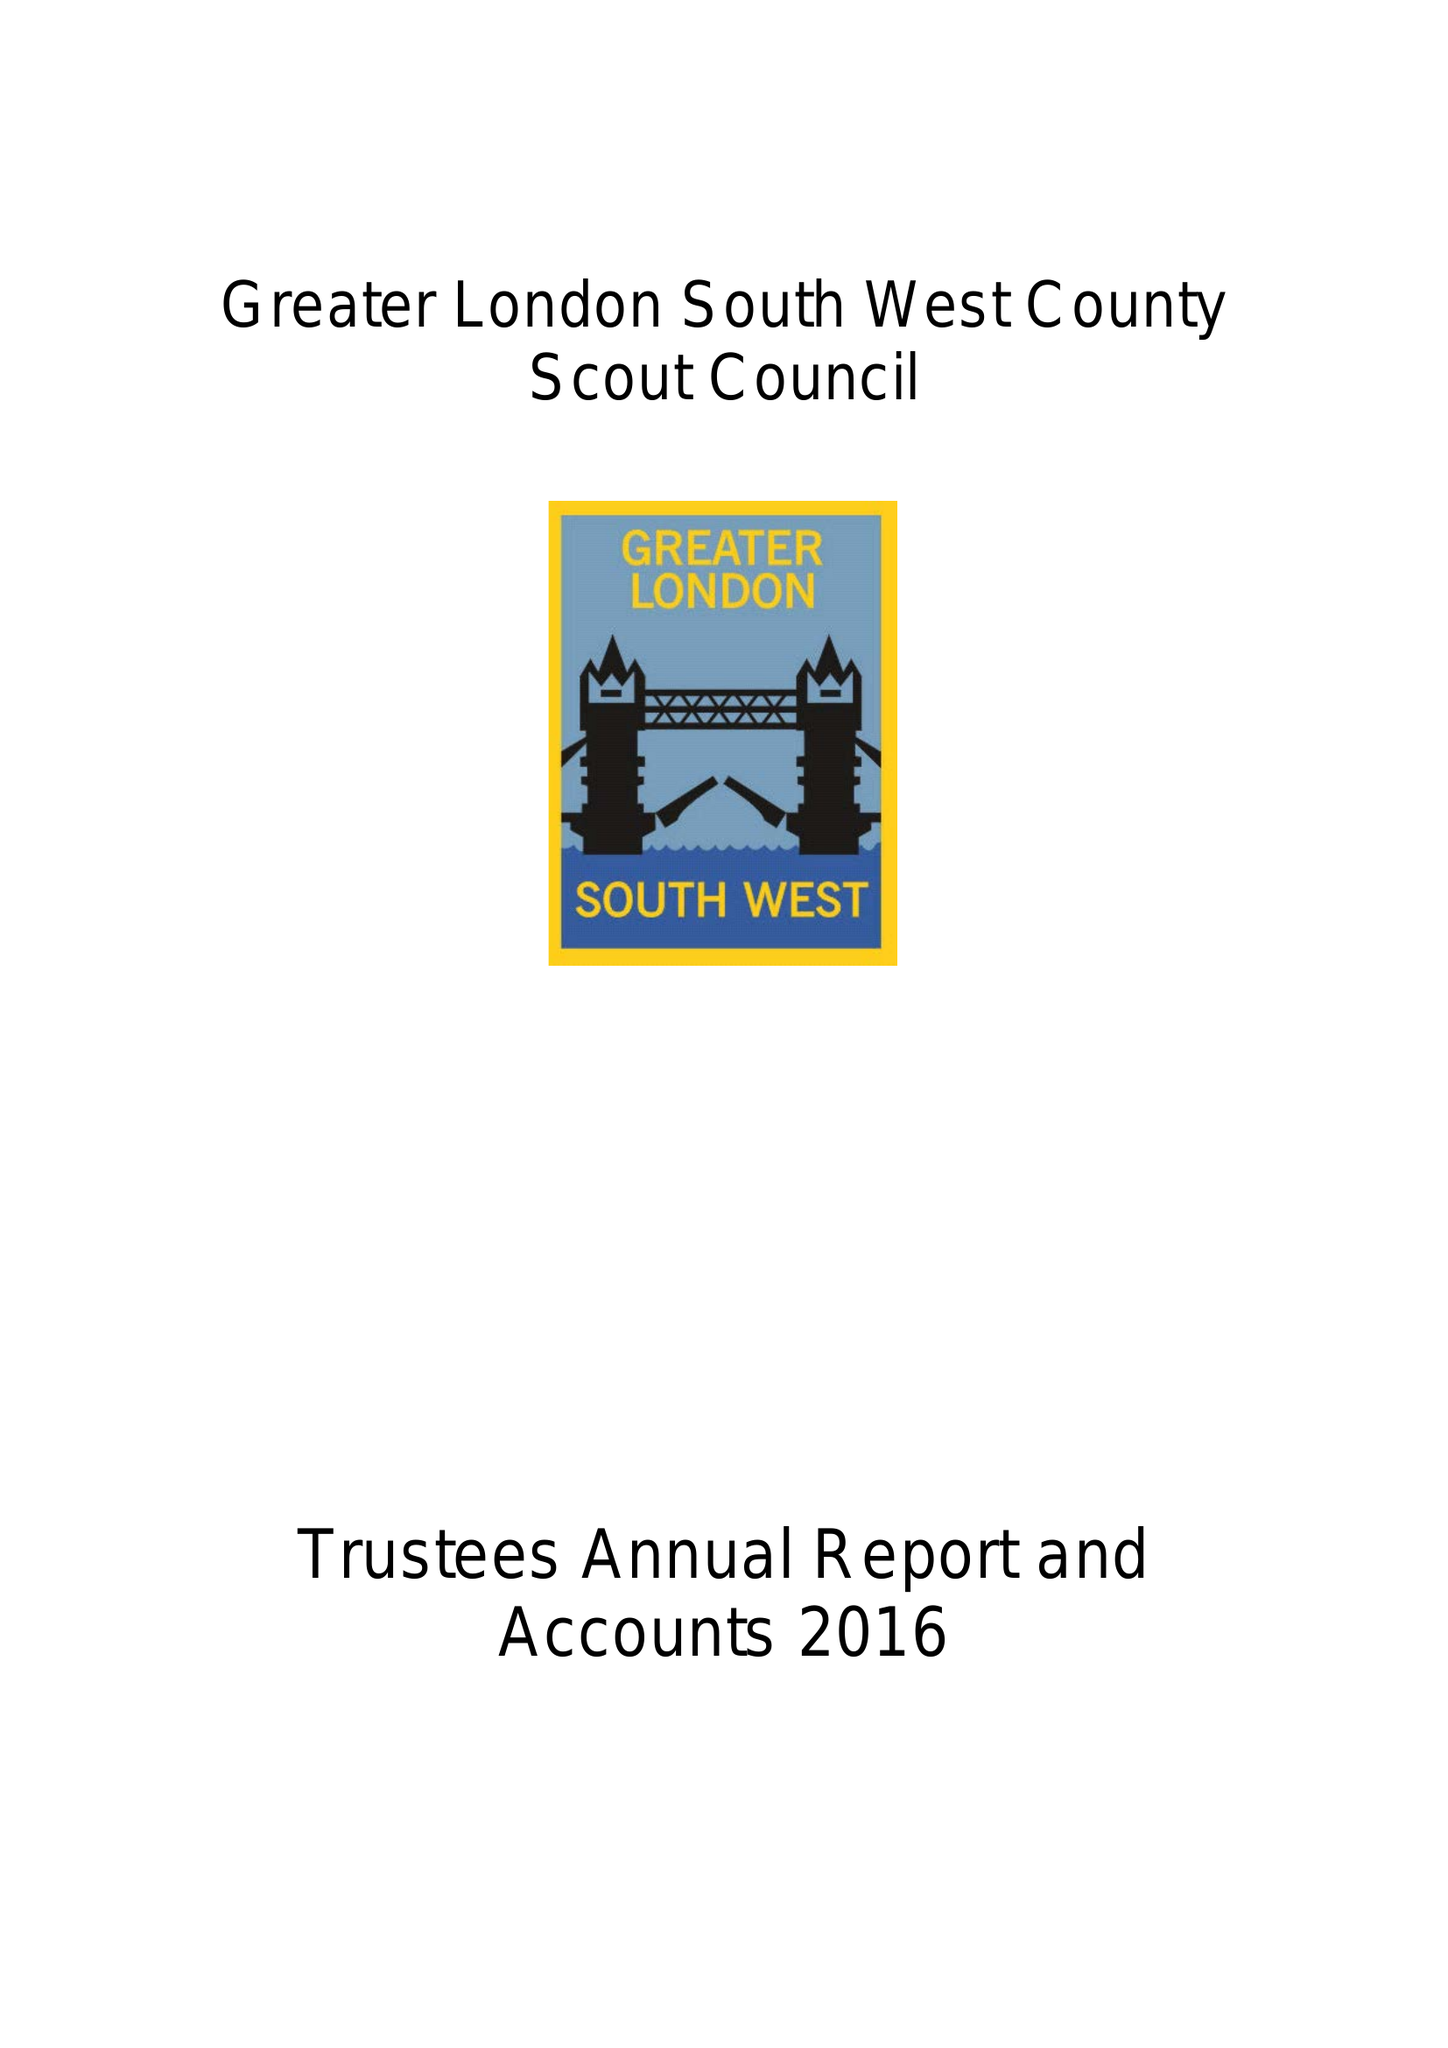What is the value for the income_annually_in_british_pounds?
Answer the question using a single word or phrase. 56040.00 